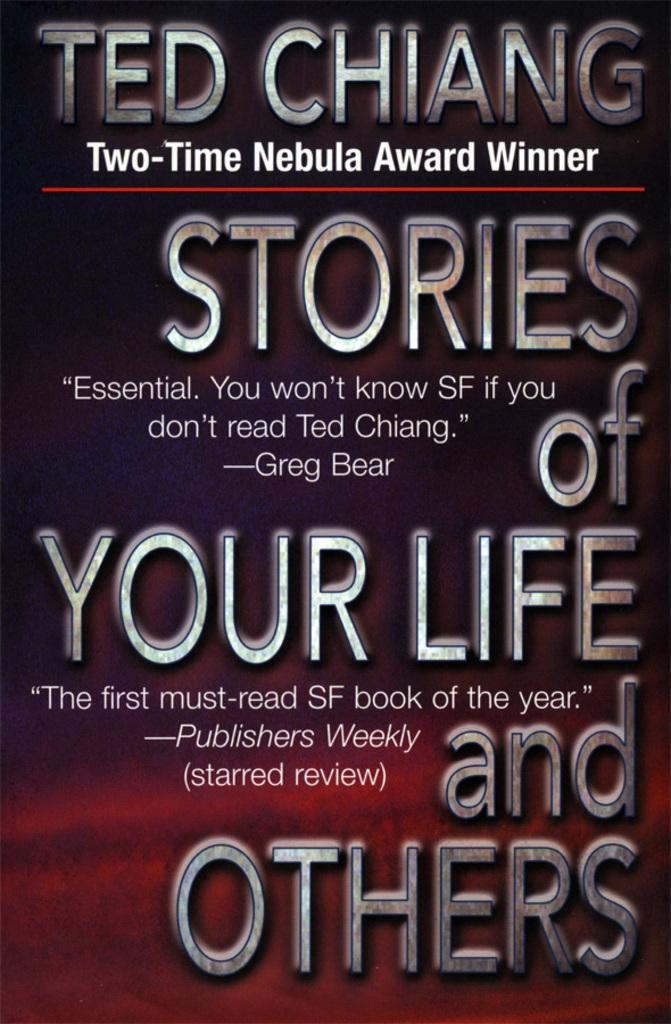<image>
Render a clear and concise summary of the photo. a book titled stories of your life and others 